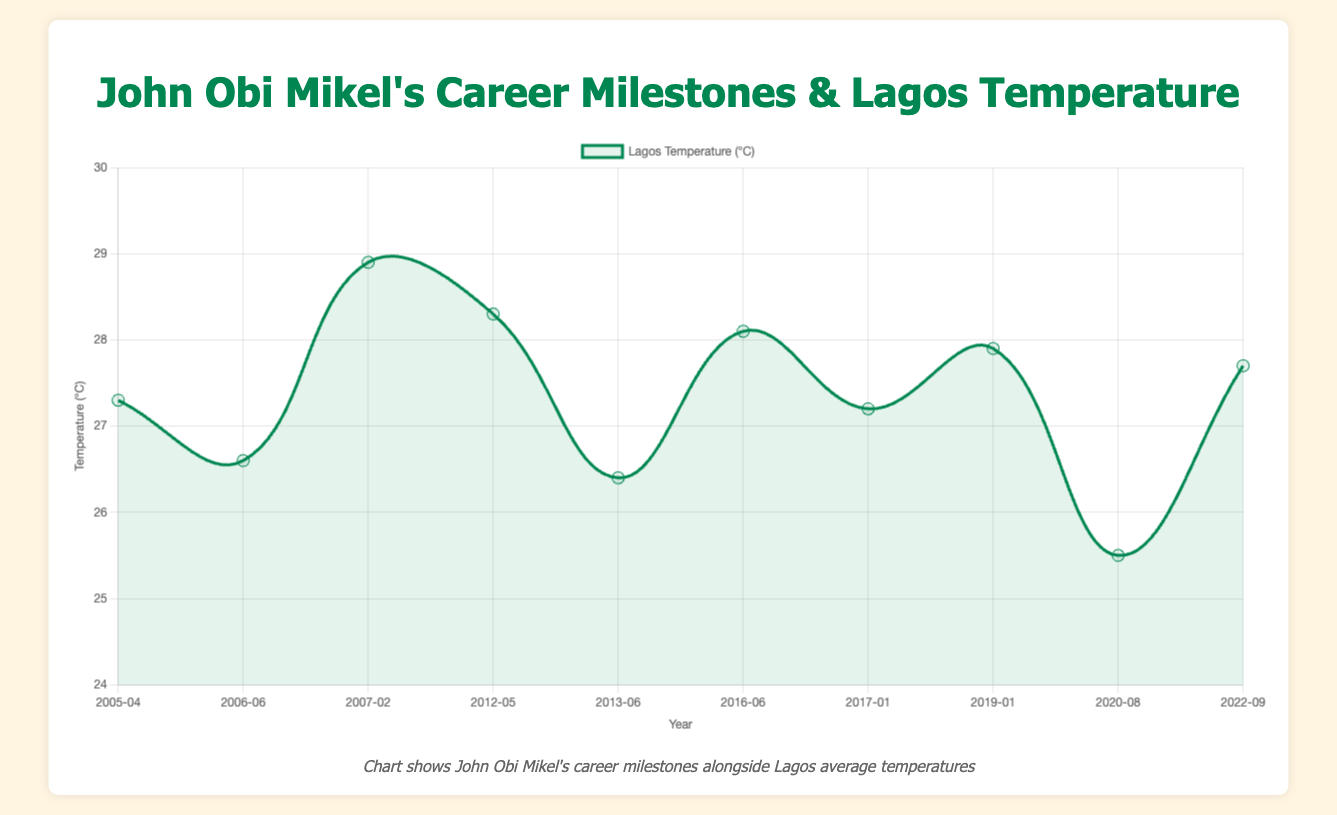What is the temperature in Lagos when John Obi Mikel signed with Chelsea in June 2006? Find the data point for "John Obi Mikel signs with Chelsea" which has the date "2006-06". The associated temperature is 26.6°C.
Answer: 26.6°C Which milestone had the highest average temperature in Lagos? Identify the milestone with the highest temperature. The highest temperature among the provided data points is 28.9°C in February 2007, when Chelsea won the League Cup Final.
Answer: Chelsea League Cup Final win Compare the temperatures in Lagos when Mikel joined Stoke City and when he announced his retirement. Which was higher? Find the temperature for both events: 25.5°C in August 2020 and 27.7°C in September 2022. Compare the two values; 27.7°C is higher than 25.5°C.
Answer: Retirement (27.7°C) What is the approximate average temperature in Lagos for all the recorded milestones? Sum all the temperatures: 27.3 + 26.6 + 28.9 + 28.3 + 26.4 + 28.1 + 27.2 + 27.9 + 25.5 + 27.7 = 274.9. Divide by the number of data points (10). 274.9 / 10 = 27.49°C.
Answer: 27.49°C Was the temperature in Lagos higher when Mikel joined Tianjin TEDA or when he signed with Middlesbrough? Compare the temperatures for both events: 27.2°C in January 2017 and 27.9°C in January 2019. 27.9°C is higher than 27.2°C.
Answer: Middlesbrough (27.9°C) How did the temperature in Lagos change from when Mikel joined Lyn in April 2005 to when Chelsea won the UEFA Champions League in May 2012? Subtract the temperature in April 2005 (27.3°C) from May 2012 (28.3°C). 28.3 - 27.3 = 1.0°C increase.
Answer: Increased by 1.0°C What was the temperature in Lagos when Mikel captained the Nigerian Olympic team and won a bronze medal in Rio in June 2016? Look for the milestone "Captain of Nigerian Olympic team" in June 2016. The temperature is 28.1°C.
Answer: 28.1°C Which milestone observed a lower temperature in Lagos: Mikel's signing with Lyn in 2005 or joining Chelsea in 2006? Compare 27.3°C in April 2005 and 26.6°C in June 2006. 26.6°C is lower.
Answer: Signing with Chelsea What was the difference in temperatures between the Confederations Cup in June 2013 and joining Tianjin TEDA in January 2017? Subtract 26.4°C (June 2013) from 27.2°C (January 2017). 27.2 - 26.4 = 0.8°C.
Answer: 0.8°C How did the temperature trend from when Mikel joined Lyn in 2005 to his announcement of retirement in 2022? Look at the temperatures at both ends: 27.3°C in April 2005 and 27.7°C in September 2022. The temperature increased from 27.3 to 27.7.
Answer: Increased 